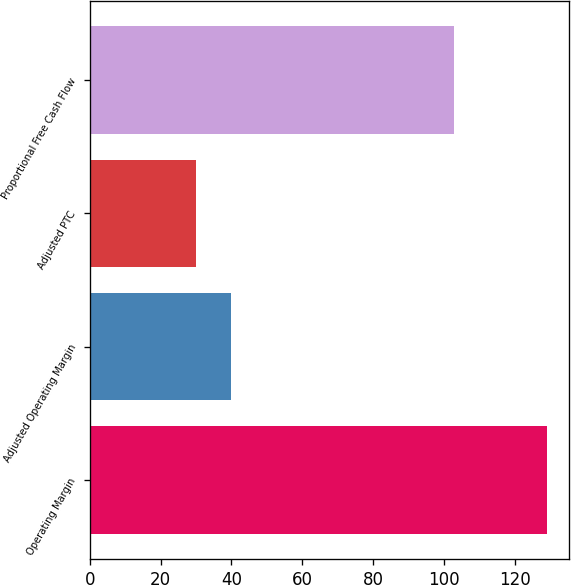Convert chart to OTSL. <chart><loc_0><loc_0><loc_500><loc_500><bar_chart><fcel>Operating Margin<fcel>Adjusted Operating Margin<fcel>Adjusted PTC<fcel>Proportional Free Cash Flow<nl><fcel>129<fcel>39.9<fcel>30<fcel>103<nl></chart> 